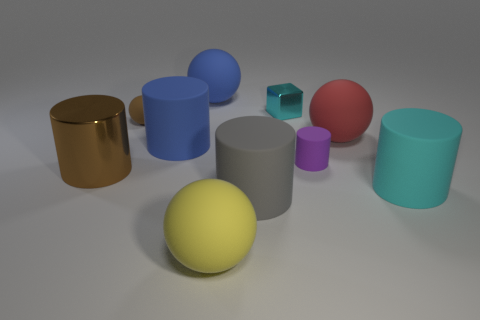There is a cylinder that is the same color as the cube; what is its size?
Your answer should be very brief. Large. What number of other objects are there of the same shape as the cyan matte object?
Provide a short and direct response. 4. What shape is the brown object in front of the tiny matte ball?
Make the answer very short. Cylinder. There is a purple thing; does it have the same shape as the metallic thing that is to the left of the large gray object?
Provide a short and direct response. Yes. There is a thing that is both left of the tiny purple cylinder and on the right side of the gray matte cylinder; what size is it?
Ensure brevity in your answer.  Small. There is a rubber ball that is both behind the red matte thing and right of the blue cylinder; what is its color?
Make the answer very short. Blue. Is the number of brown metallic objects that are in front of the brown metal cylinder less than the number of purple matte objects behind the brown matte sphere?
Your answer should be compact. No. Is there anything else that has the same color as the small cylinder?
Your response must be concise. No. The brown rubber thing has what shape?
Your answer should be compact. Sphere. What is the color of the tiny cylinder that is made of the same material as the big yellow thing?
Offer a terse response. Purple. 